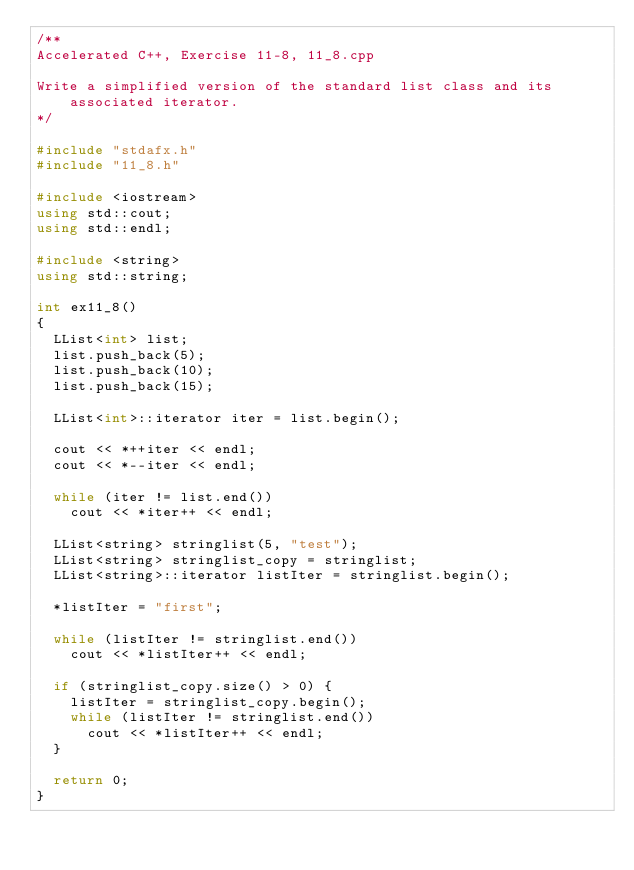<code> <loc_0><loc_0><loc_500><loc_500><_C++_>/**
Accelerated C++, Exercise 11-8, 11_8.cpp

Write a simplified version of the standard list class and its associated iterator.
*/

#include "stdafx.h"
#include "11_8.h"

#include <iostream>
using std::cout;
using std::endl;

#include <string>
using std::string;

int ex11_8()
{
  LList<int> list;
  list.push_back(5);
  list.push_back(10);
  list.push_back(15);

  LList<int>::iterator iter = list.begin();

  cout << *++iter << endl;
  cout << *--iter << endl;

  while (iter != list.end())
    cout << *iter++ << endl;

  LList<string> stringlist(5, "test");
  LList<string> stringlist_copy = stringlist;
  LList<string>::iterator listIter = stringlist.begin();

  *listIter = "first";

  while (listIter != stringlist.end())
    cout << *listIter++ << endl;

  if (stringlist_copy.size() > 0) {
    listIter = stringlist_copy.begin();
    while (listIter != stringlist.end())
      cout << *listIter++ << endl;
  }

  return 0;
}</code> 